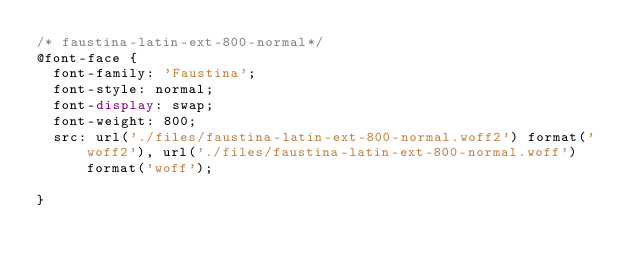<code> <loc_0><loc_0><loc_500><loc_500><_CSS_>/* faustina-latin-ext-800-normal*/
@font-face {
  font-family: 'Faustina';
  font-style: normal;
  font-display: swap;
  font-weight: 800;
  src: url('./files/faustina-latin-ext-800-normal.woff2') format('woff2'), url('./files/faustina-latin-ext-800-normal.woff') format('woff');
  
}
</code> 